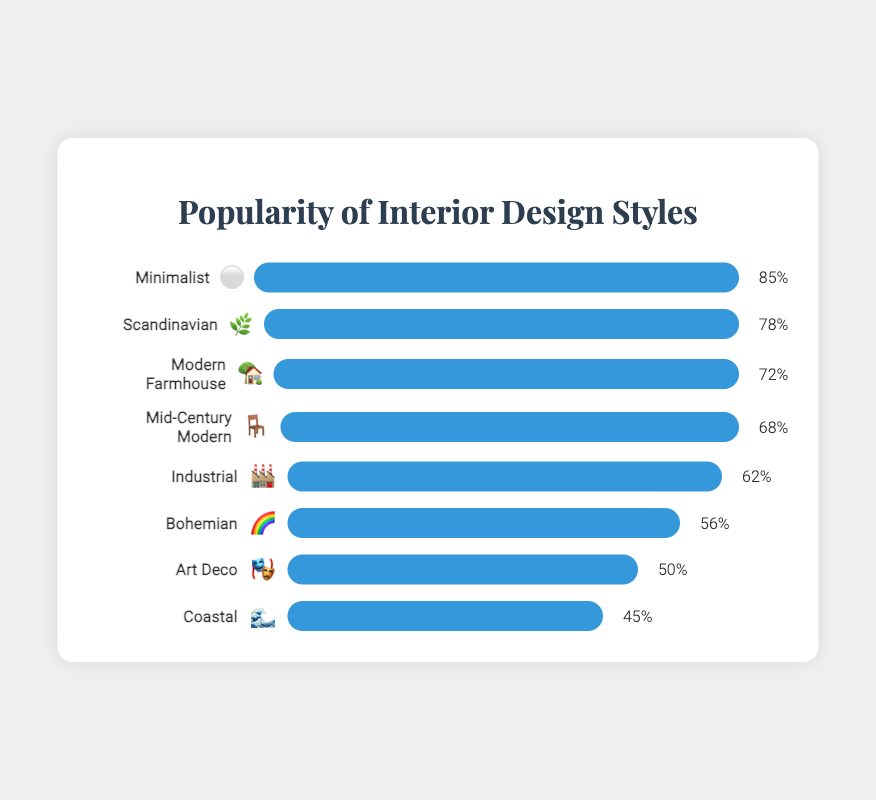what is the title of the figure? The title is displayed at the top of the figure, formatted in a larger and possibly stylized font, typically used to convey the main subject of the chart.
Answer: Popularity of Interior Design Styles Which design style has the highest popularity? The design style with the highest popularity can be identified by finding the bar that extends the furthest to the right.
Answer: Minimalist What Emoji represents the Coastal design style? Each design style is represented by an Emoji next to its name. For Coastal, we find the corresponding Emoji in the chart.
Answer: 🌊 What's the difference in popularity between the most and least popular design styles? Subtract the popularity percentage of the least popular design style from the most popular one. Minimalist has 85%, and Coastal has 45%. The difference is calculated as 85 - 45.
Answer: 40 How many design styles have a popularity of 70% or more? Count the number of bars with a width representing 70% or higher in popularity. Minimalist, Scandinavian, Modern Farmhouse, and Mid-Century Modern meet this criterion.
Answer: 4 Compare the popularity of Modern Farmhouse and Industrial. Which one is more popular and by how much? Find the popularity percentages of Modern Farmhouse (72%) and Industrial (62%) and subtract the latter from the former. 72 - 62 gives the difference.
Answer: Modern Farmhouse, by 10% What is the average popularity of Scandinavian and Bohemian styles? Add the popularity percentages of Scandinavian (78%) and Bohemian (56%) and then divide by 2. (78 + 56) / 2 = 67
Answer: 67% Which design style is associated with the emoji 🎭? Look for the design style next to the emoji 🎭 in the chart.
Answer: Art Deco What is the combined popularity percentage of styles representing natural elements (Scandinavian 🌿 and Bohemian 🌈)? Sum the popularity percentages of Scandinavian (78%) and Bohemian (56%). 78 + 56 = 134
Answer: 134% Which design styles have a popularity percentage closest to each other and what is that difference? Calculate the differences between consecutive popularity percentages: Modern Farmhouse (72%) and Mid-Century Modern (68%) have the smallest difference. 72 - 68 = 4
Answer: Modern Farmhouse and Mid-Century Modern, 4 